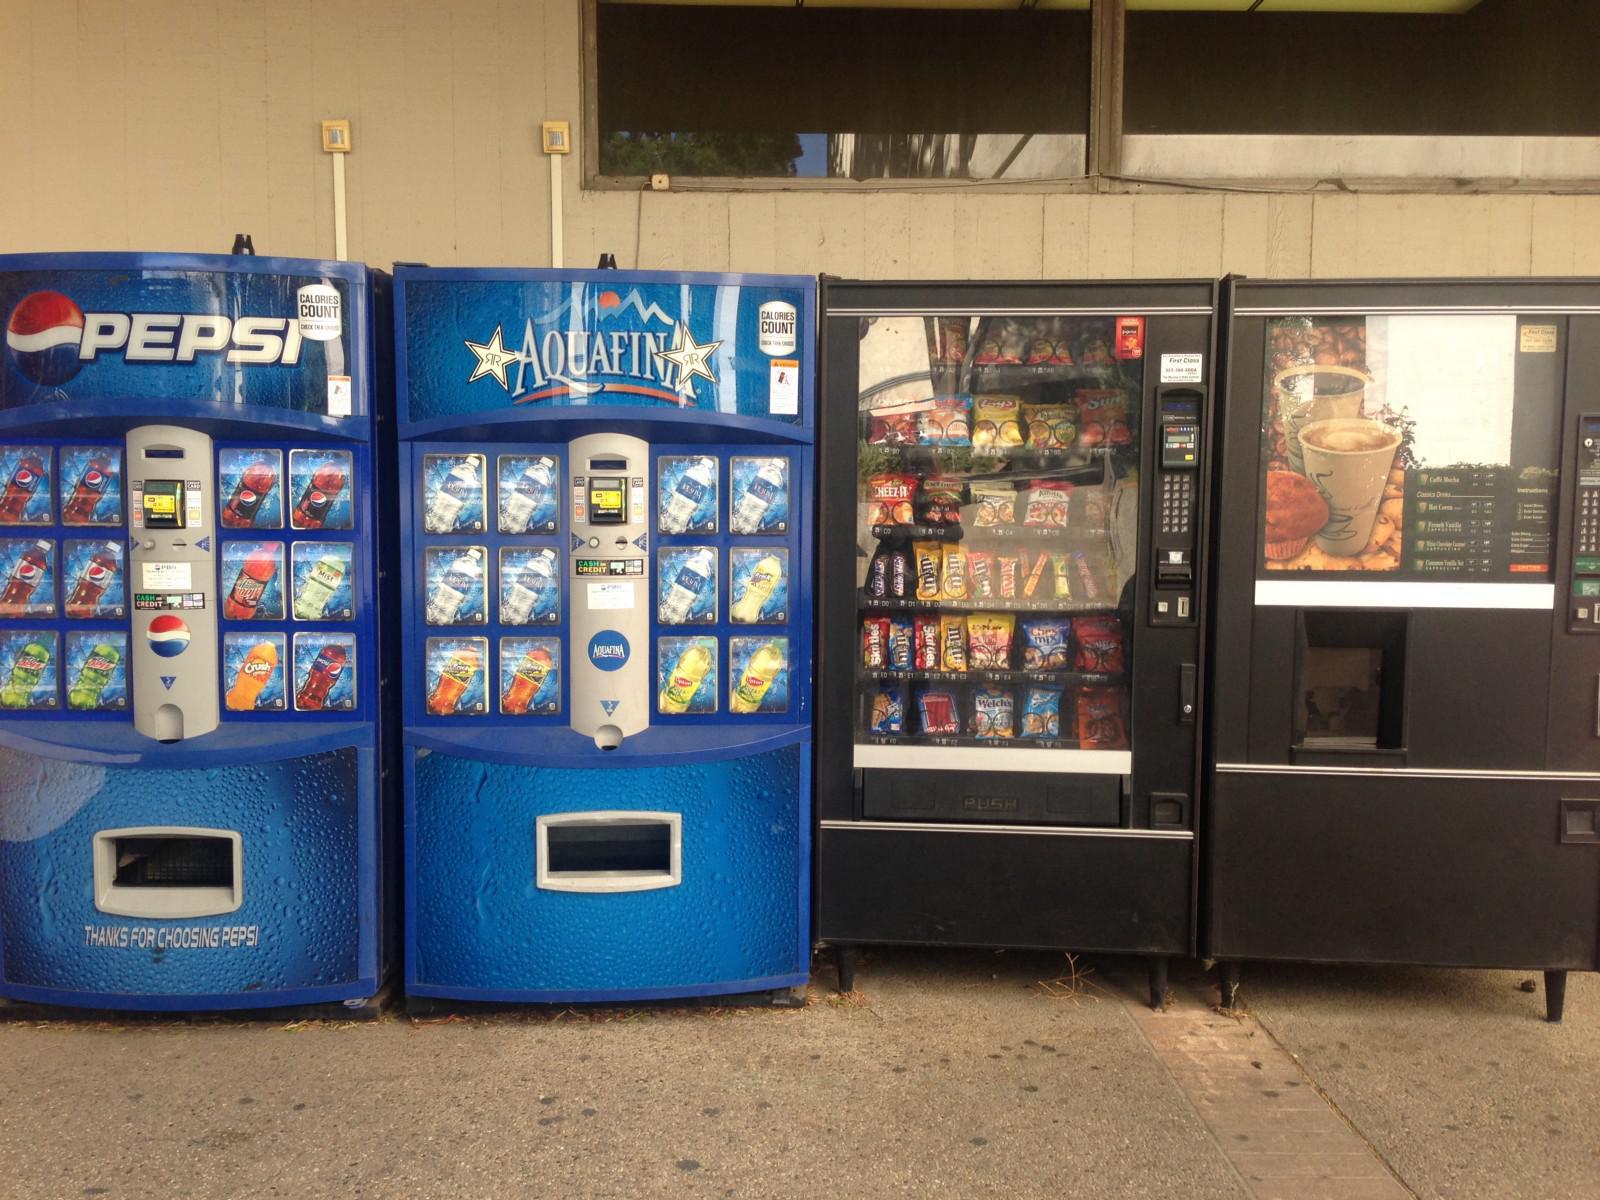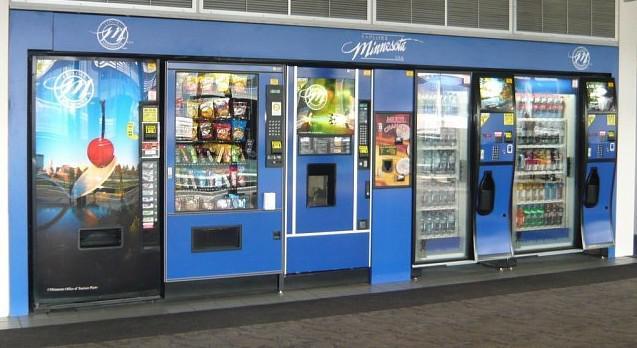The first image is the image on the left, the second image is the image on the right. For the images shown, is this caption "In one of the images, a pepsi machine stands alone." true? Answer yes or no. No. The first image is the image on the left, the second image is the image on the right. For the images displayed, is the sentence "Each image prominently features exactly one vending machine, which is blue." factually correct? Answer yes or no. No. The first image is the image on the left, the second image is the image on the right. Considering the images on both sides, is "Each image shows predominantly one vending machine, and all vending machines shown are blue." valid? Answer yes or no. No. The first image is the image on the left, the second image is the image on the right. Considering the images on both sides, is "There are more machines in the image on the right than in the image on the left." valid? Answer yes or no. Yes. 